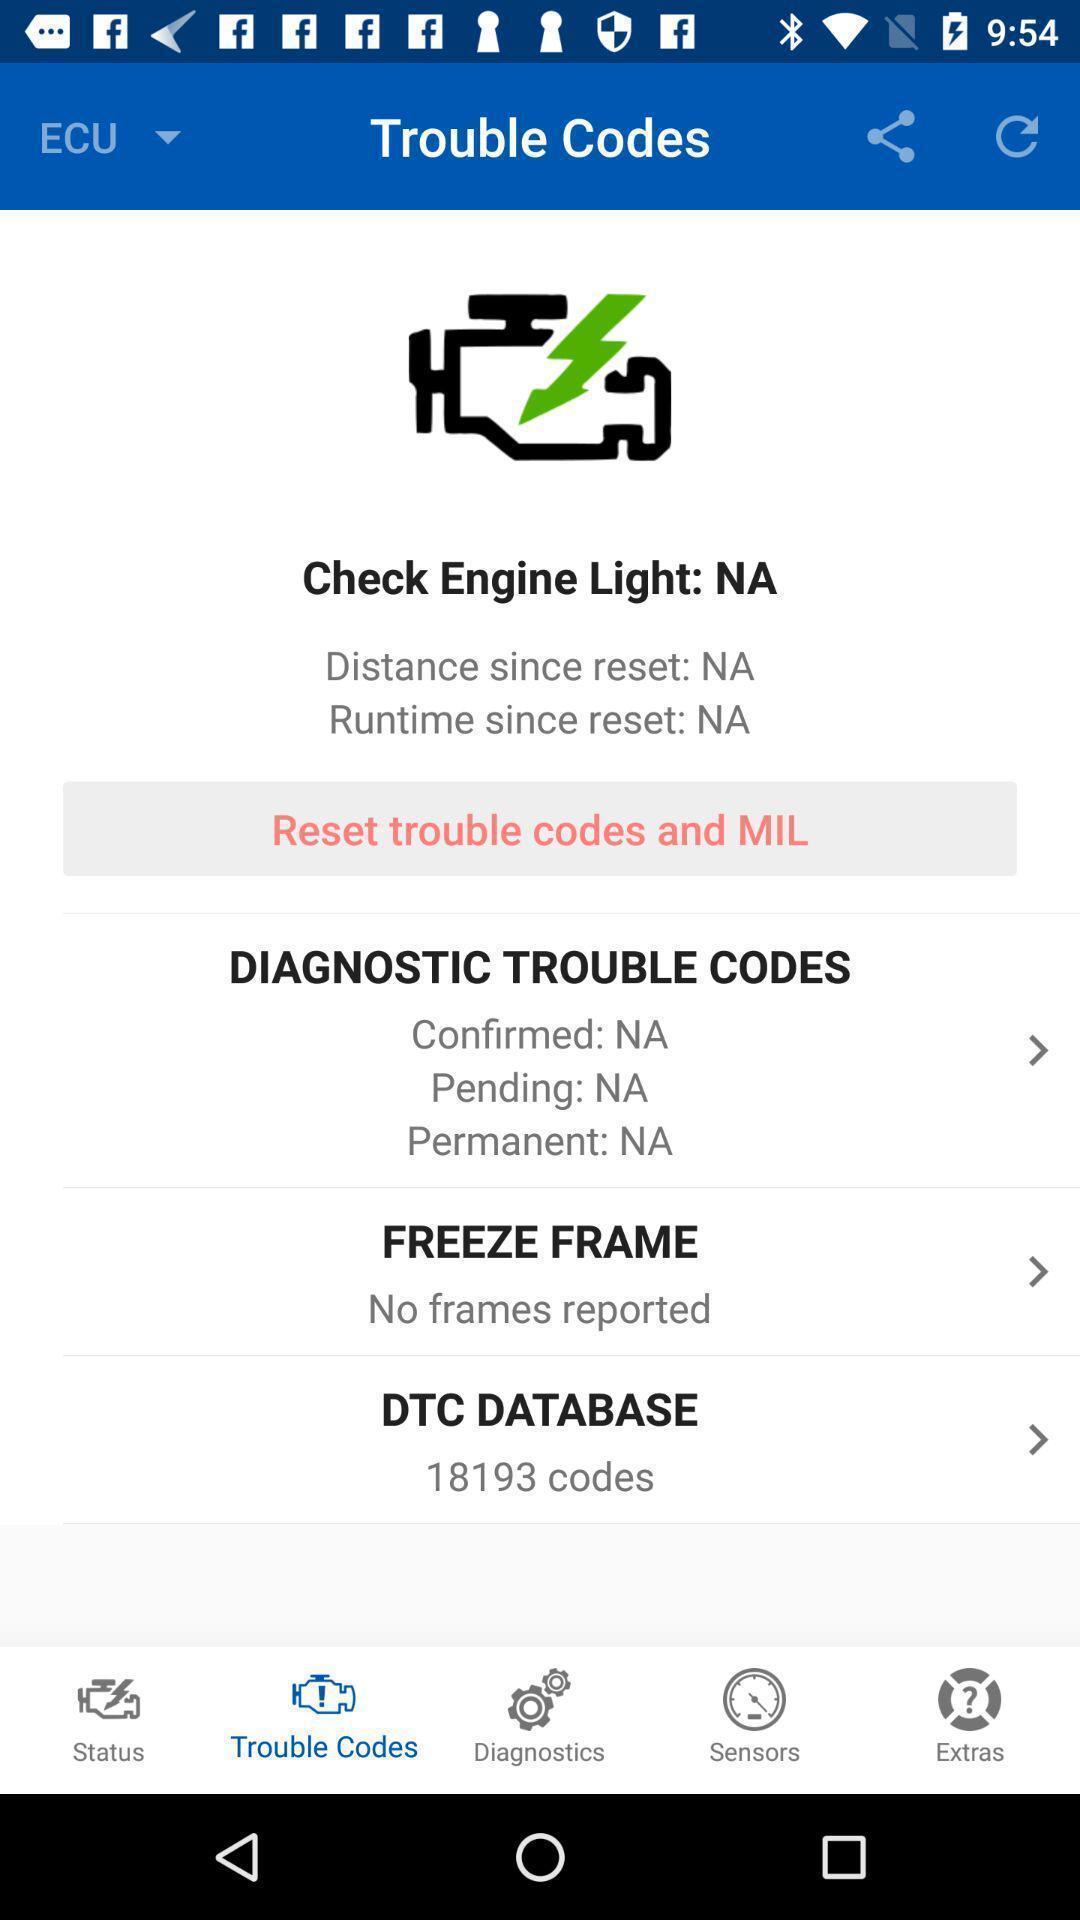Give me a narrative description of this picture. Page showing different settings for trouble code. 